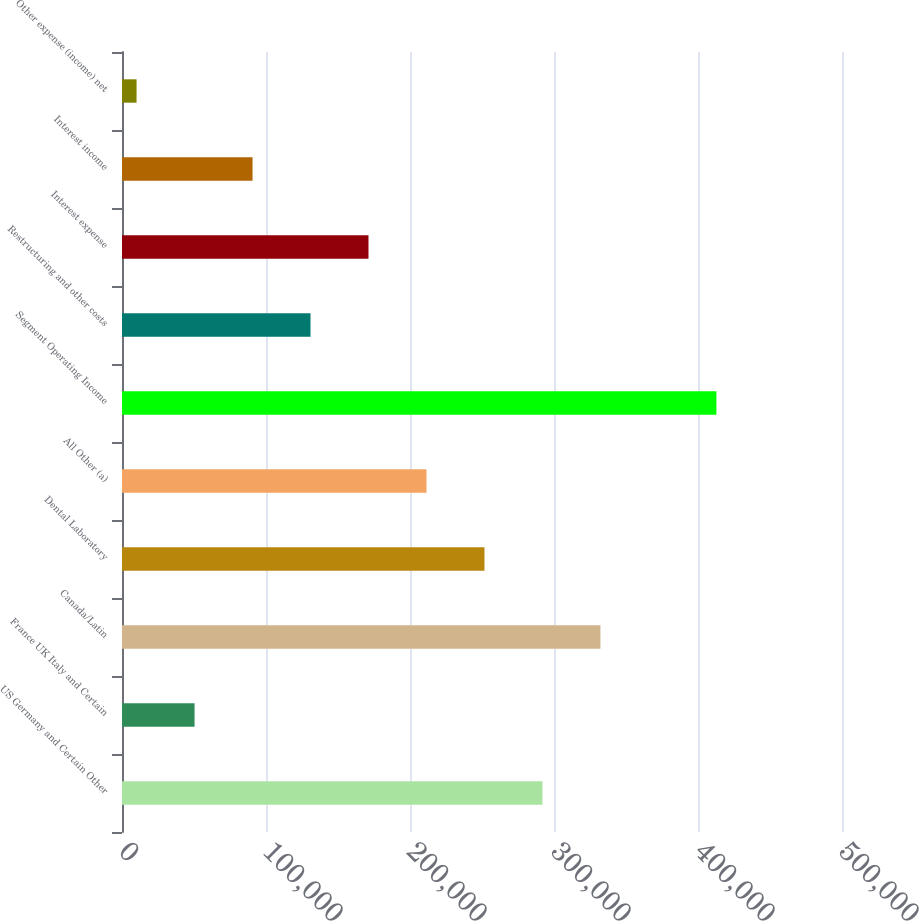Convert chart. <chart><loc_0><loc_0><loc_500><loc_500><bar_chart><fcel>US Germany and Certain Other<fcel>France UK Italy and Certain<fcel>Canada/Latin<fcel>Dental Laboratory<fcel>All Other (a)<fcel>Segment Operating Income<fcel>Restructuring and other costs<fcel>Interest expense<fcel>Interest income<fcel>Other expense (income) net<nl><fcel>291976<fcel>50376.6<fcel>332243<fcel>251710<fcel>211443<fcel>412776<fcel>130910<fcel>171176<fcel>90643.2<fcel>10110<nl></chart> 